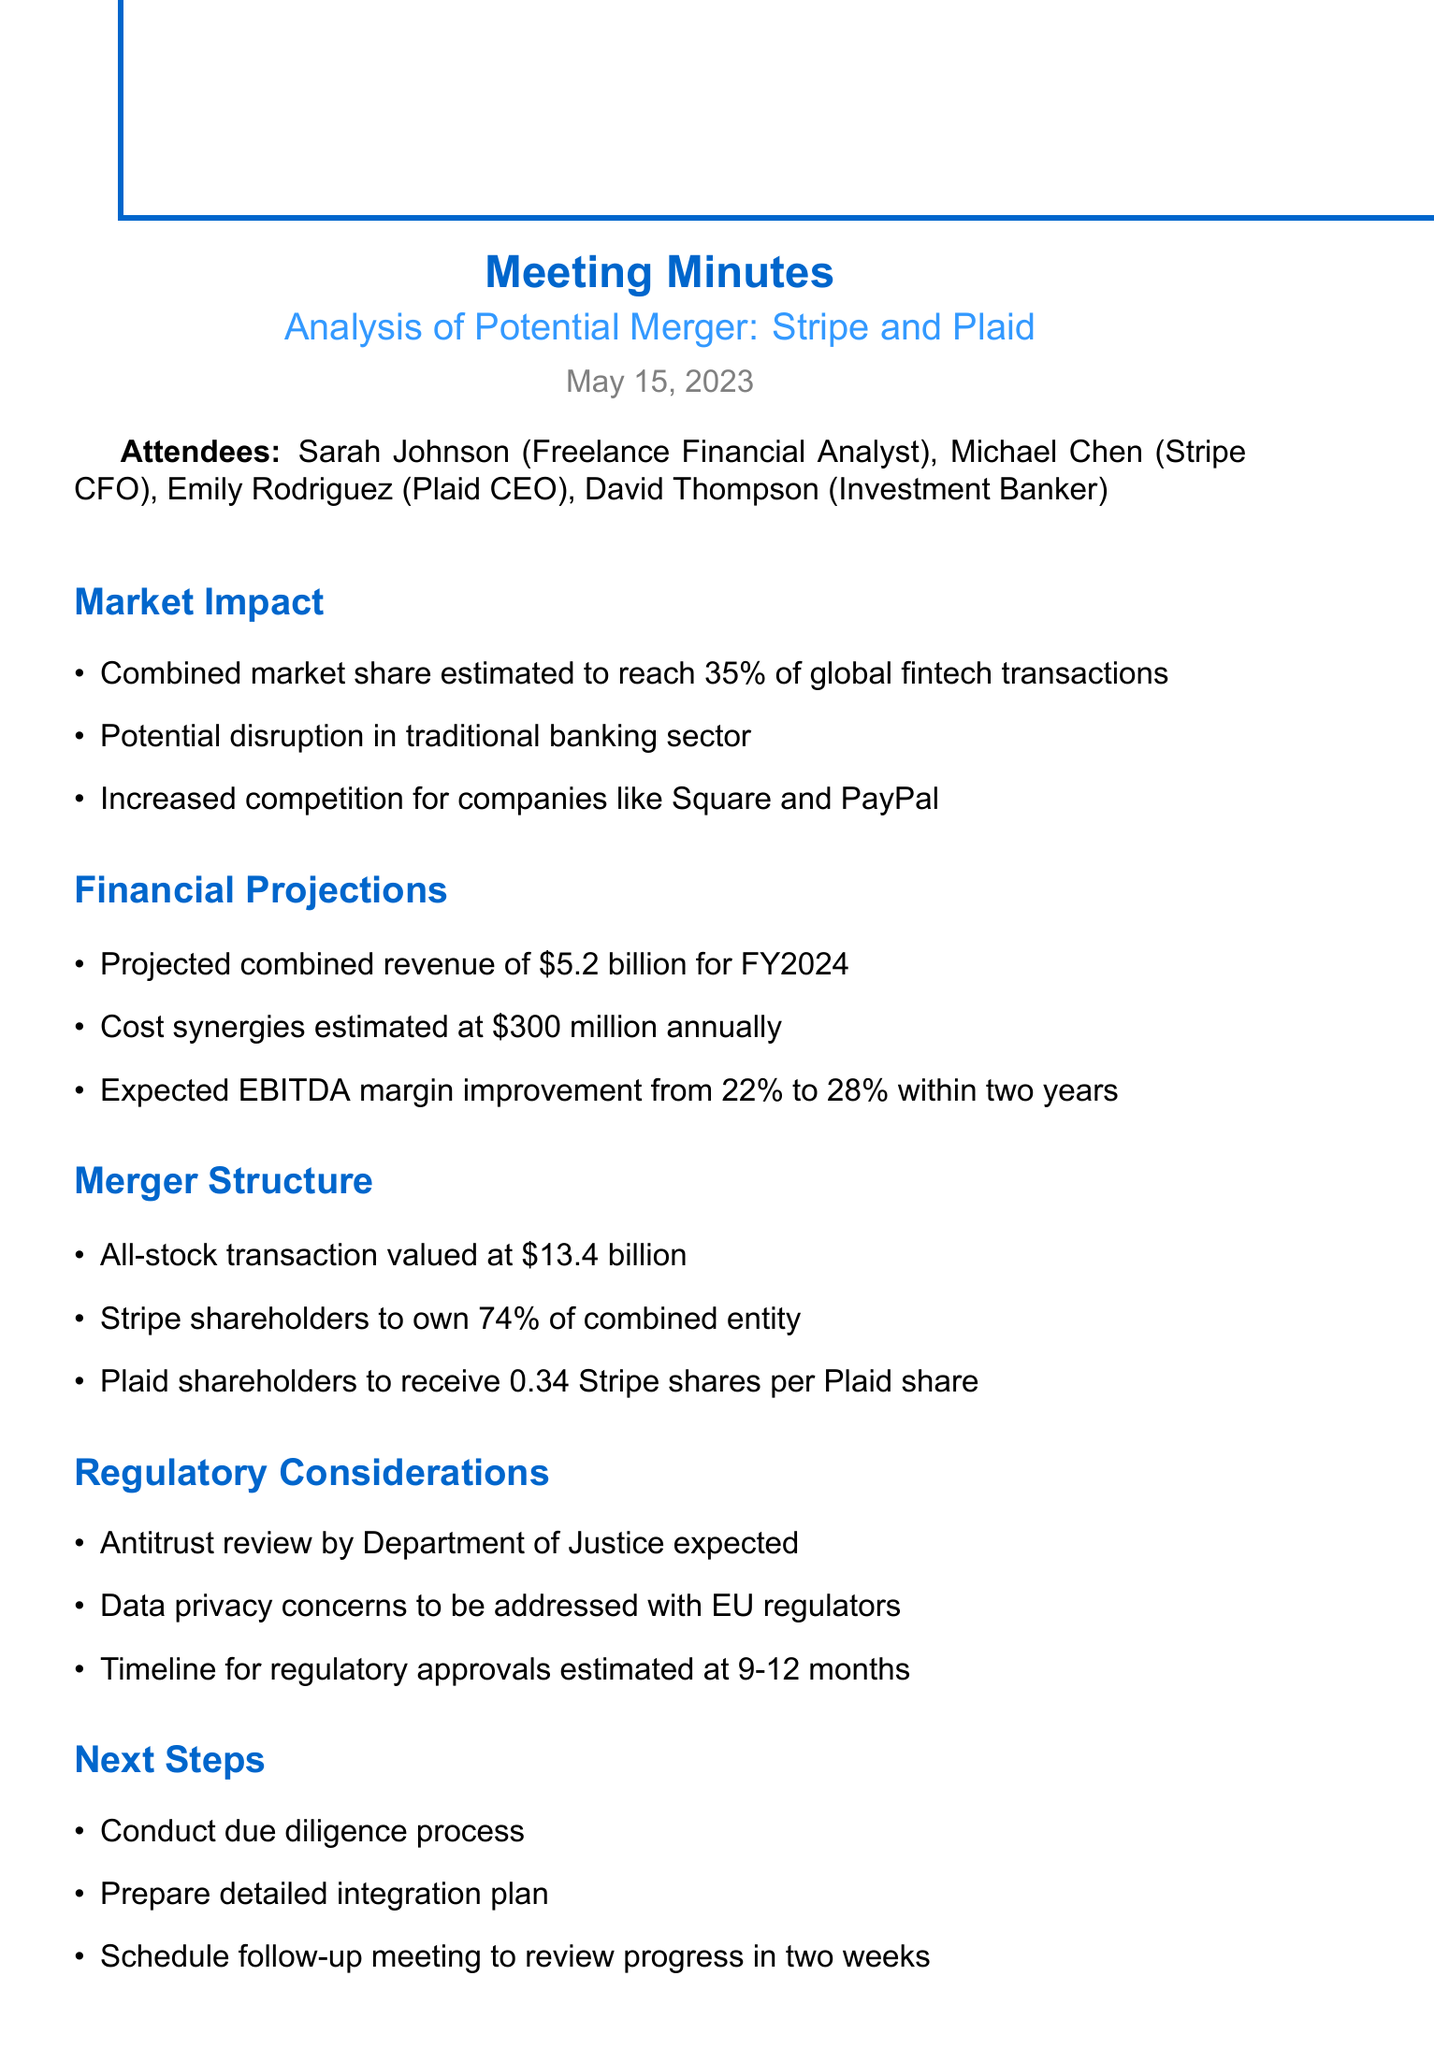What is the date of the meeting? The date of the meeting is specified at the beginning of the document.
Answer: May 15, 2023 Who are the attendees from Stripe? The attendees listed in the document include a specific person from Stripe.
Answer: Michael Chen What is the estimated combined market share? The document states the combined market share as a percentage of global fintech transactions.
Answer: 35% What is the projected combined revenue for FY2024? The projected combined revenue is mentioned in the financial projections section of the document.
Answer: $5.2 billion What type of transaction is this merger? The merger structure section describes the nature of the transaction.
Answer: All-stock What is the estimated cost synergies annually? The financial projections section provides details on cost synergies expected from the merger.
Answer: $300 million How long is the estimated timeline for regulatory approvals? The regulatory considerations section addresses the timeline for regulatory approvals.
Answer: 9-12 months What will Plaid shareholders receive per share of Plaid? The merger structure section specifies the compensation for Plaid shareholders.
Answer: 0.34 Stripe shares per Plaid share What is the follow-up meeting scheduled for? The next steps section indicates the purpose of the follow-up meeting.
Answer: Review progress in two weeks 